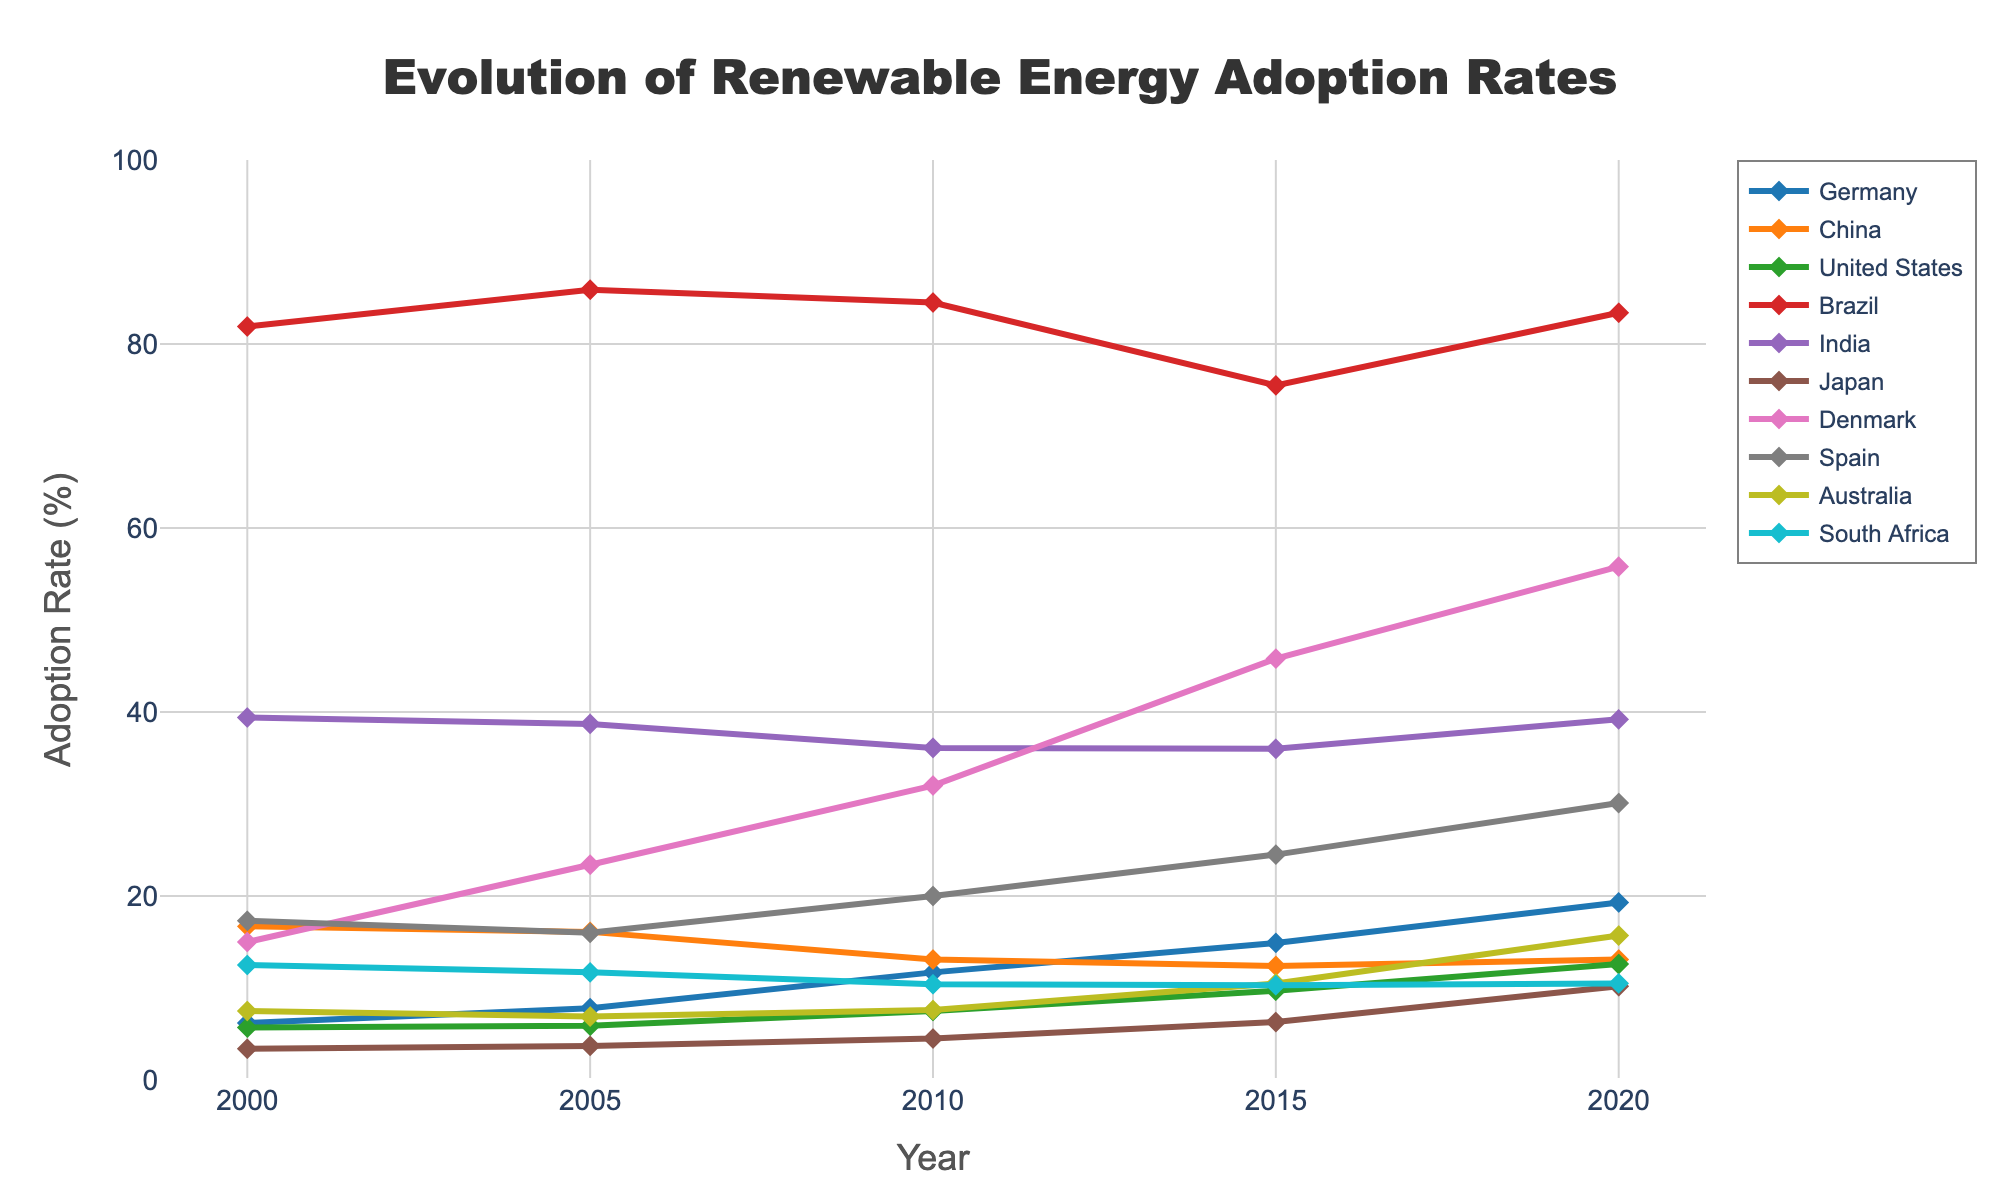Which country had the highest renewable energy adoption rate in 2020? Look at the 2020 column and identify the country with the highest value. The highest value is 83.4% for Brazil.
Answer: Brazil By how much did Denmark's renewable energy adoption rate increase between 2010 and 2015? Subtract Denmark's 2010 rate from the 2015 rate.
45.8 - 32.0 = 13.8
Answer: 13.8 Compare the renewable energy adoption rates of Germany and the United States in 2020. Which country has a higher rate? Check the 2020 adoption rates for Germany (19.3%) and the United States (12.6%). Germany's rate is higher.
Answer: Germany What is the average renewable energy adoption rate for Spain across all years provided? Sum up Spain's adoption rates for each year and divide by the number of years.
(17.3 + 16.0 + 20.0 + 24.5 + 30.1) / 5 = 21.58
Answer: 21.58 Which country had a decrease in renewable energy adoption rate from 2000 to 2005? Compare the 2000 and 2005 rates for each country, and identify those with a decrease.
China: 16.7 to 16.1
India: 39.4 to 38.7
Australia: 7.5 to 6.9
South Africa: 12.5 to 11.7
These countries had a decrease, with South Africa having the largest decrease of 0.8%.
Answer: South Africa Which two countries had the closest renewable energy adoption rates in 2015? Check the 2015 values and find the smallest difference between any two countries.
Germany: 14.9
China: 12.4
United States: 9.7
Brazil: 75.5
India: 36.0
Japan: 6.3
Denmark: 45.8
Spain: 24.5
Australia: 10.5
South Africa: 10.3
The closet rates in 2015 are Australia (10.5%) and South Africa (10.3%) with a difference of 0.2%.
Answer: Australia and South Africa 